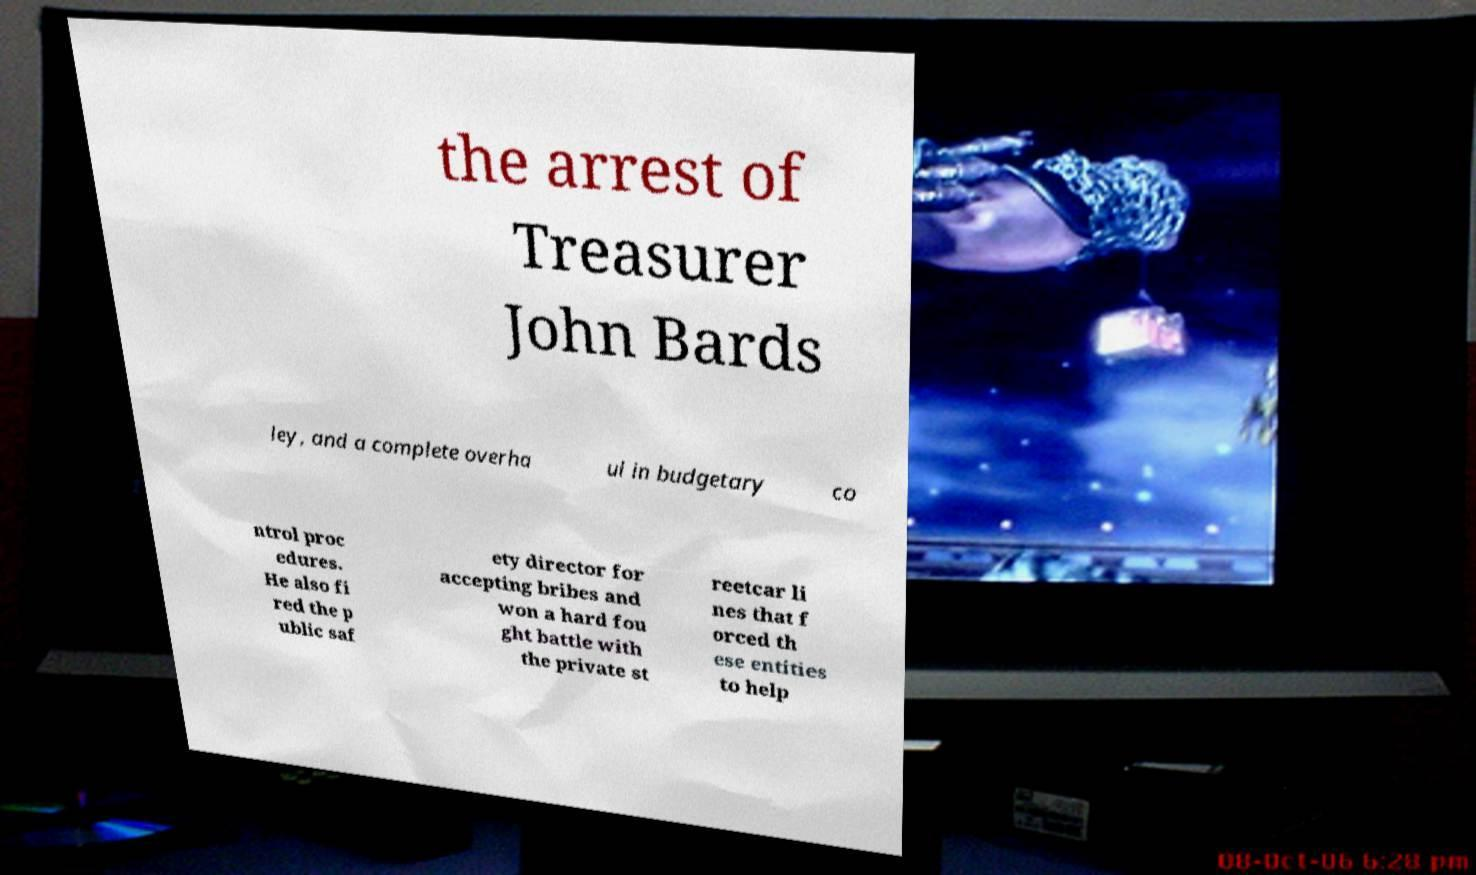Could you assist in decoding the text presented in this image and type it out clearly? the arrest of Treasurer John Bards ley, and a complete overha ul in budgetary co ntrol proc edures. He also fi red the p ublic saf ety director for accepting bribes and won a hard fou ght battle with the private st reetcar li nes that f orced th ese entities to help 